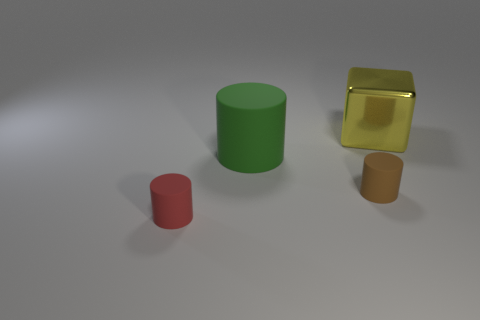There is a cylinder that is on the right side of the large object in front of the large yellow metal cube; what is it made of?
Your answer should be very brief. Rubber. What number of yellow things have the same shape as the large green object?
Offer a terse response. 0. There is a cylinder that is behind the cylinder that is to the right of the big thing that is in front of the large yellow block; what is its size?
Provide a succinct answer. Large. How many gray objects are either metallic objects or small things?
Your answer should be very brief. 0. There is a object behind the big rubber cylinder; is its shape the same as the brown thing?
Keep it short and to the point. No. Is the number of objects that are left of the big matte cylinder greater than the number of brown rubber things?
Keep it short and to the point. No. How many brown matte things have the same size as the block?
Offer a very short reply. 0. How many objects are either tiny red objects or big objects in front of the cube?
Your response must be concise. 2. The object that is both to the right of the big green cylinder and in front of the shiny cube is what color?
Ensure brevity in your answer.  Brown. Is the metal block the same size as the red cylinder?
Make the answer very short. No. 